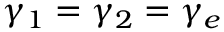<formula> <loc_0><loc_0><loc_500><loc_500>\gamma _ { 1 } = \gamma _ { 2 } = \gamma _ { e }</formula> 